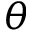<formula> <loc_0><loc_0><loc_500><loc_500>\theta</formula> 